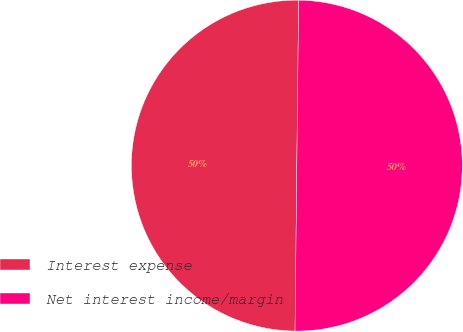<chart> <loc_0><loc_0><loc_500><loc_500><pie_chart><fcel>Interest expense<fcel>Net interest income/margin<nl><fcel>50.0%<fcel>50.0%<nl></chart> 